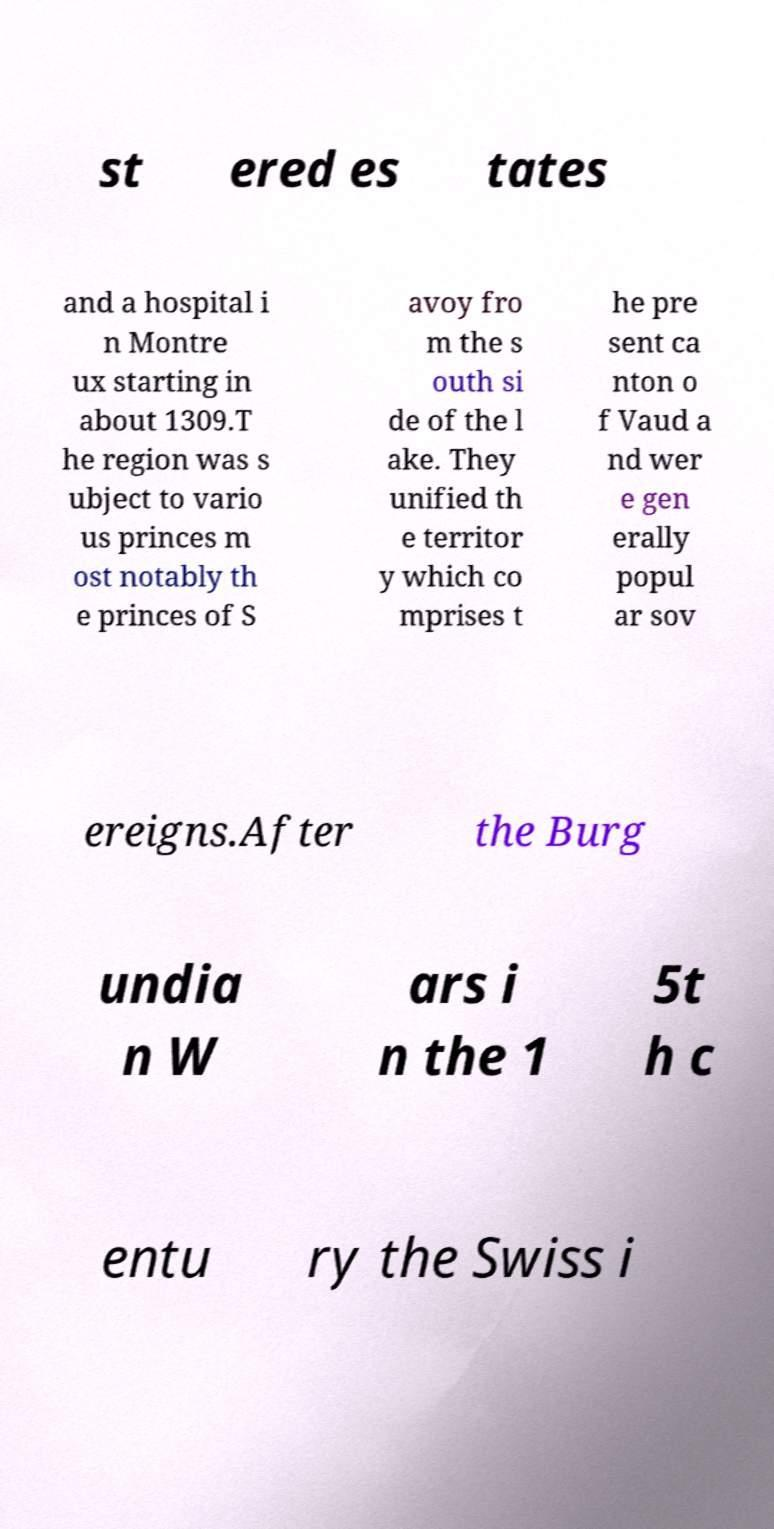Please read and relay the text visible in this image. What does it say? st ered es tates and a hospital i n Montre ux starting in about 1309.T he region was s ubject to vario us princes m ost notably th e princes of S avoy fro m the s outh si de of the l ake. They unified th e territor y which co mprises t he pre sent ca nton o f Vaud a nd wer e gen erally popul ar sov ereigns.After the Burg undia n W ars i n the 1 5t h c entu ry the Swiss i 